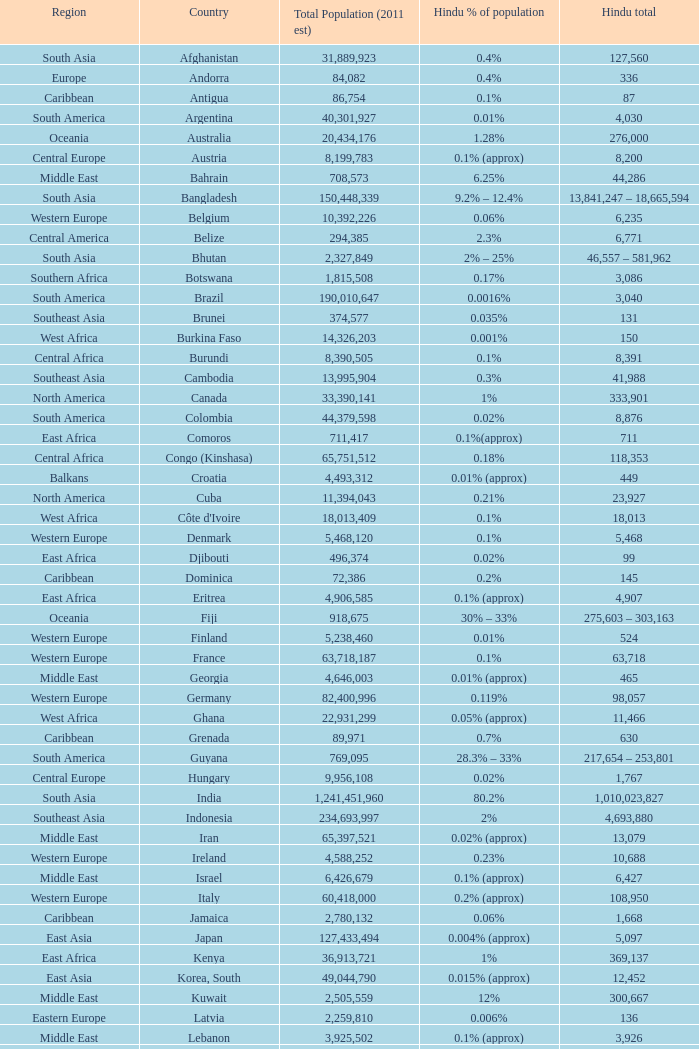Total Population (2011 est) larger than 30,262,610, and a Hindu total of 63,718 involves what country? France. 